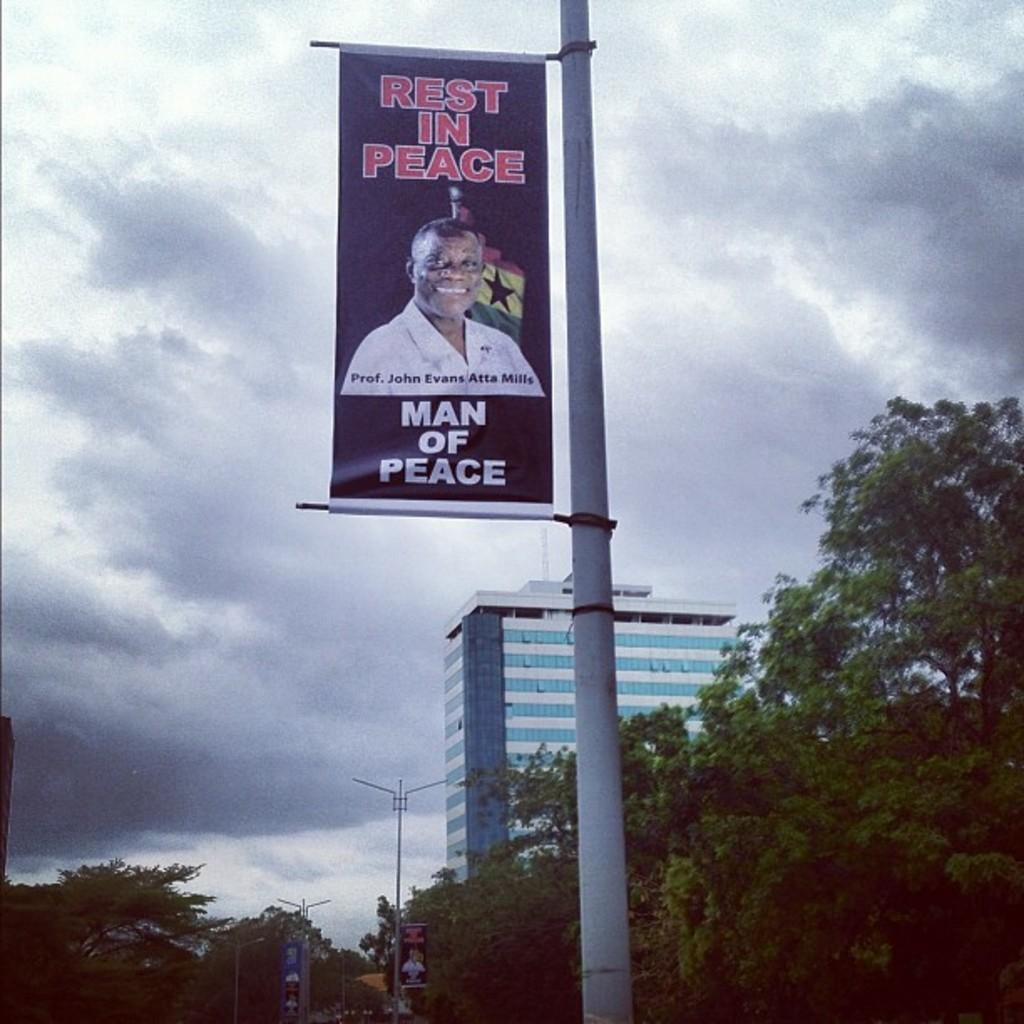<image>
Provide a brief description of the given image. Professor John Evans Atta Mills, Man of Peace, has passed away. 